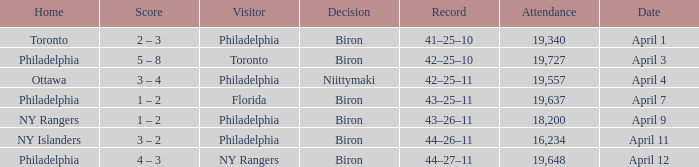Who were the visitors when the home team were the ny rangers? Philadelphia. 